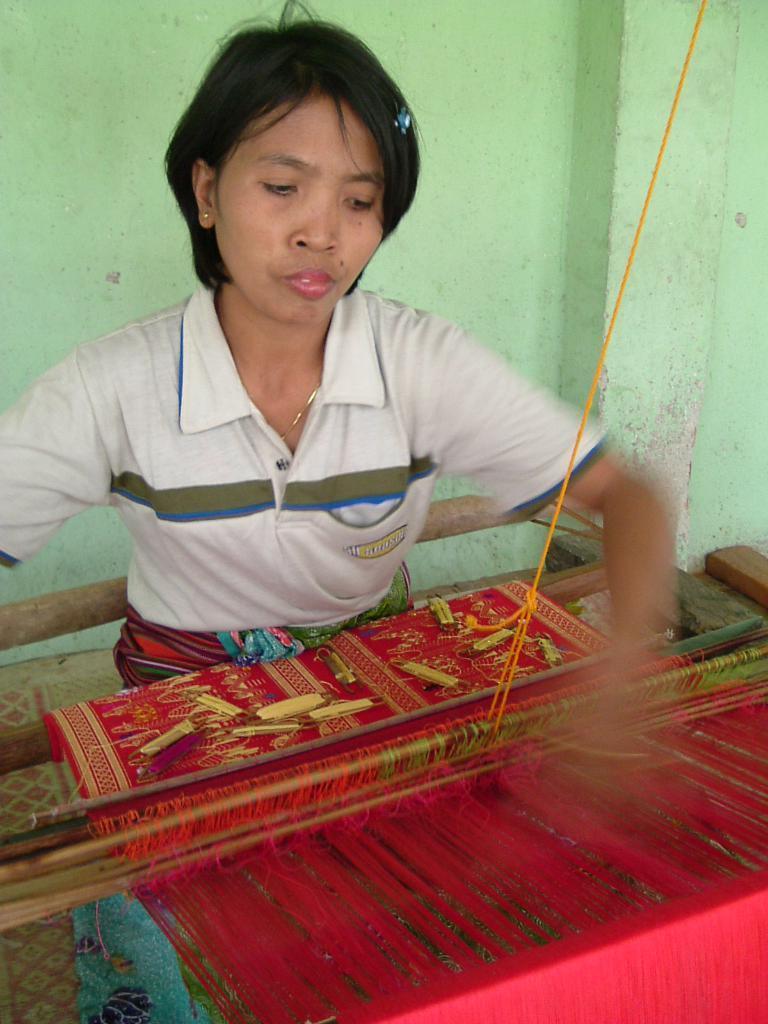Please provide a concise description of this image. In this image I can see a woman and I can see she is wearing a white colour t-shirt. In the front of her I can see a red colour carpet and an equipment. I can also see few things on the carpet. 